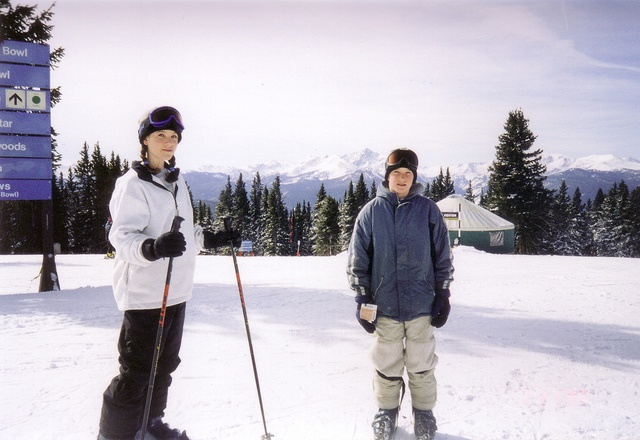Describe the objects in this image and their specific colors. I can see people in black, lightgray, gray, and darkgray tones and people in black, gray, and darkgray tones in this image. 